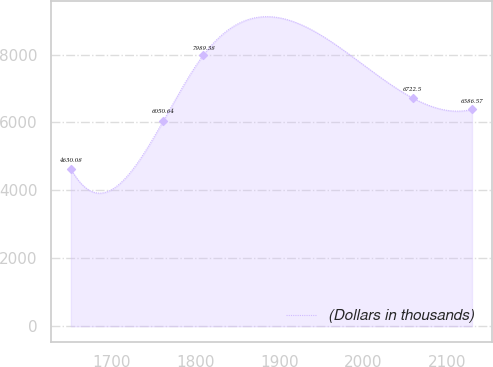Convert chart to OTSL. <chart><loc_0><loc_0><loc_500><loc_500><line_chart><ecel><fcel>(Dollars in thousands)<nl><fcel>1651.47<fcel>4630.08<nl><fcel>1761.76<fcel>6050.64<nl><fcel>1809.58<fcel>7989.38<nl><fcel>2058.88<fcel>6722.5<nl><fcel>2129.69<fcel>6386.57<nl></chart> 